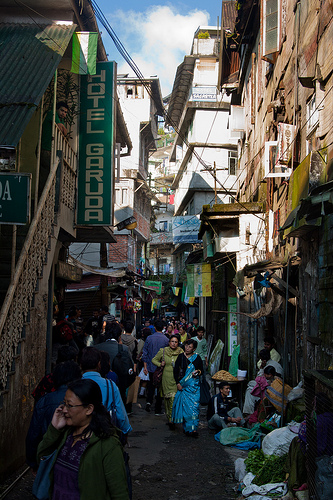<image>
Is there a woman in the building? No. The woman is not contained within the building. These objects have a different spatial relationship. 